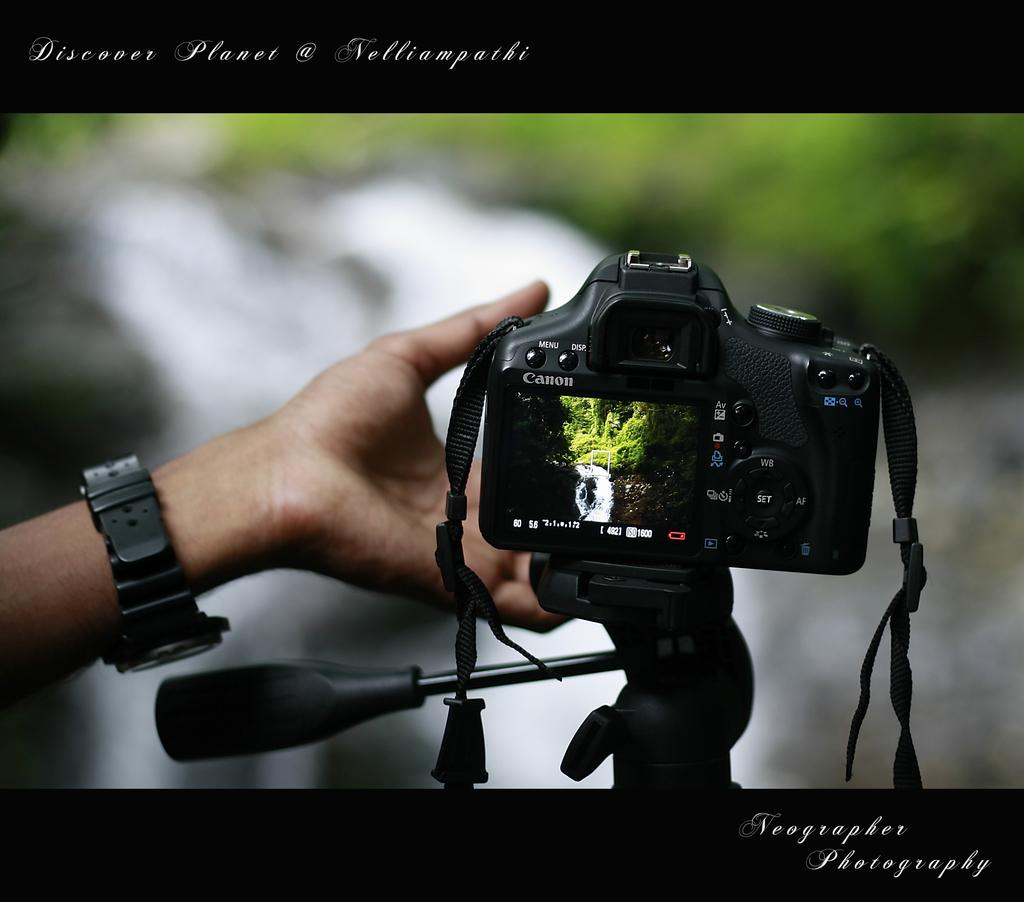<image>
Render a clear and concise summary of the photo. Person holding a camera for the brand Canon wihle taking a picture. 